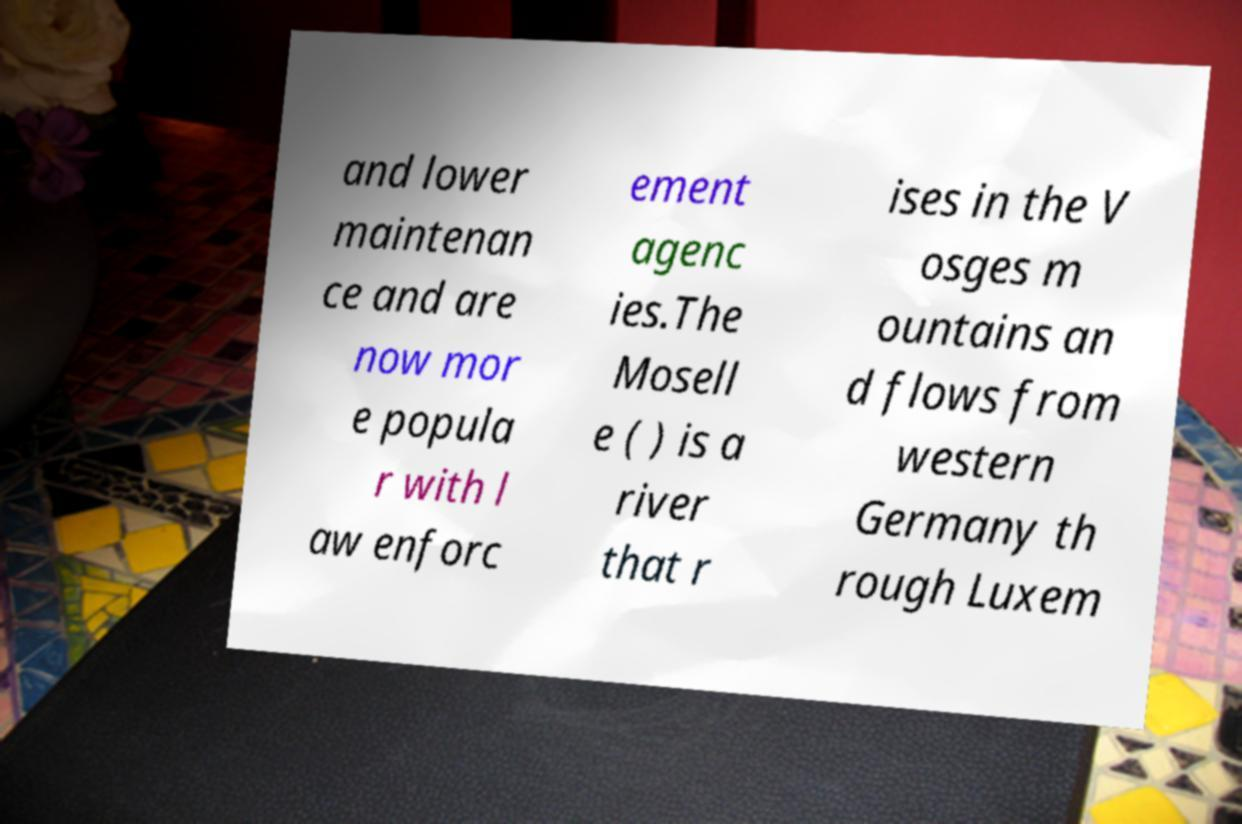I need the written content from this picture converted into text. Can you do that? and lower maintenan ce and are now mor e popula r with l aw enforc ement agenc ies.The Mosell e ( ) is a river that r ises in the V osges m ountains an d flows from western Germany th rough Luxem 